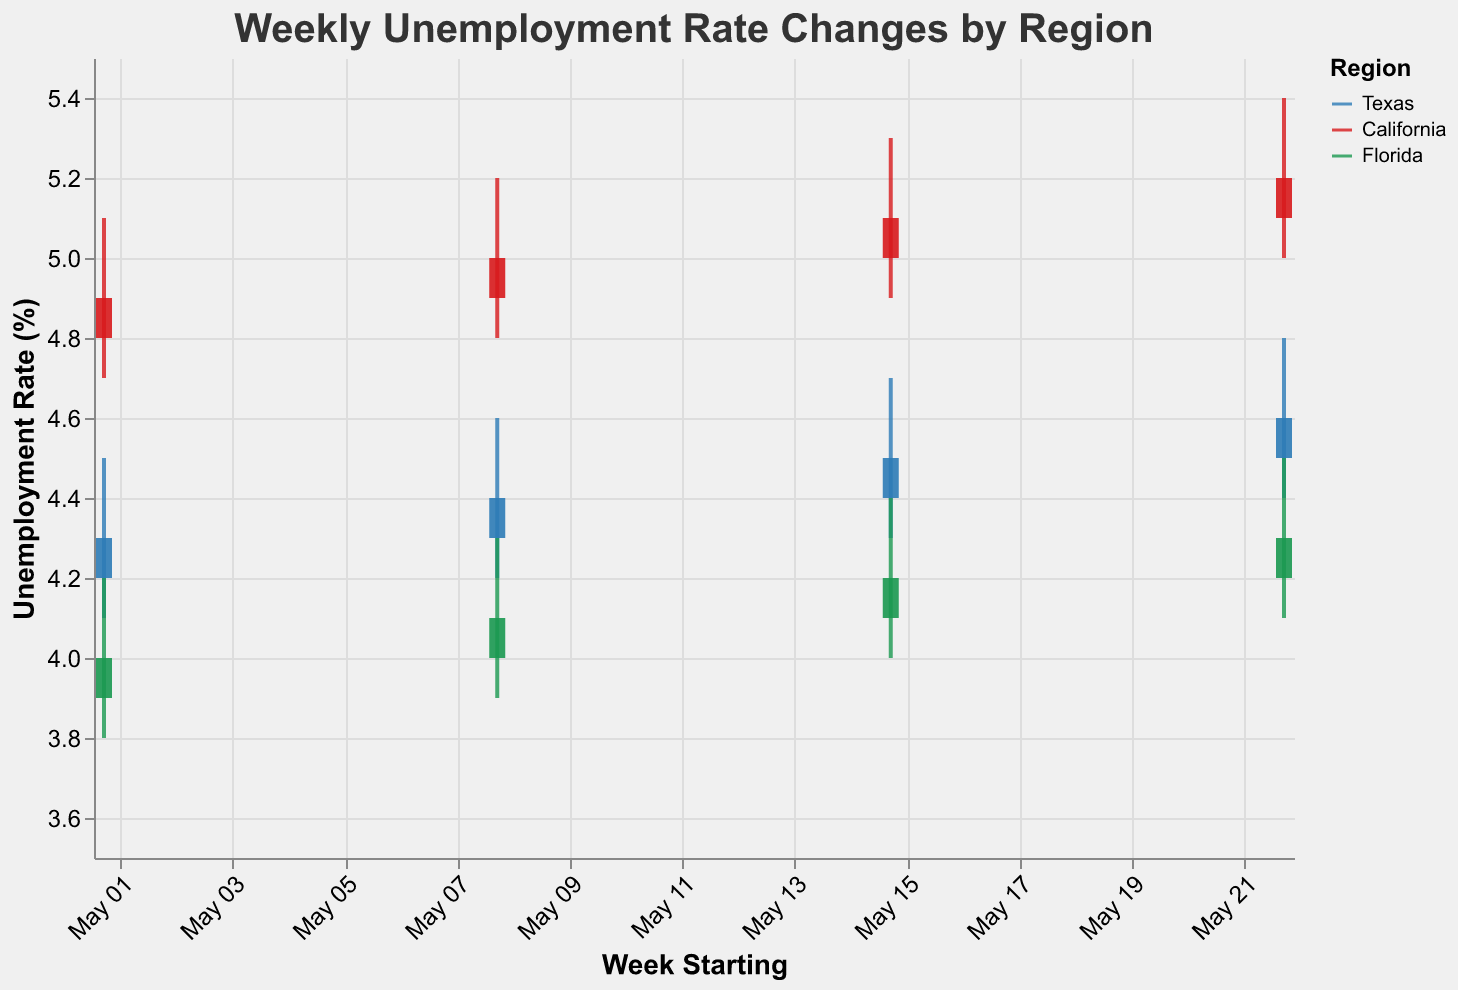How does the unemployment rate in Texas change over the four weeks in May 2023? In the chart, observe the Close values for Texas from May 1 to May 22. The values are 4.3%, 4.4%, 4.5%, and 4.6%, respectively.
Answer: It increases from 4.3% to 4.6% Which region had the highest starting unemployment rate in the first week of May 2023? Check the Open values for all regions for the date of May 1, 2023. California has the highest starting unemployment rate at 4.8%.
Answer: California What is the average unemployment rate in Florida over the four weeks of May 2023? Sum the Close values for Florida over the four weeks (4.0 + 4.1 + 4.2 + 4.3 = 16.6), then divide by the number of weeks (16.6 / 4 = 4.15).
Answer: 4.15% Which region shows the most significant increase in the unemployment rate from the start to the end of May 2023? Compare the difference between the first and last Close values for each region: Texas (4.6 - 4.3 = 0.3), California (5.2 - 4.9 = 0.3), Florida (4.3 - 4.0 = 0.3). All regions have an equal increase of 0.3%.
Answer: All regions have equal increases How does the range of unemployment rates in Texas compare with California in the third week of May 2023? For the week starting on May 15, compare the High and Low values for Texas (4.7 - 4.3 = 0.4) and California (5.3 - 4.9 = 0.4). The range is the same for both regions, 0.4%.
Answer: The range is the same, 0.4% Which region had the lowest unemployment rate at the end of the third week of May 2023? Look at the Close values for all regions for the date of May 15, 2023. Florida's is the lowest at 4.2%.
Answer: Florida On which date was the unemployment rate variability the highest in California? Find the date with the highest difference between High and Low for California. The maximum difference is 5.4 - 5.0 = 0.4 on May 22.
Answer: May 22 Compare the unemployment rate variability between Texas and Florida in the second week of May 2023. Check the High and Low values for Texas (4.6 - 4.2 = 0.4) and Florida (4.3 - 3.9 = 0.4) for the week starting on May 8. The variability is the same, 0.4%.
Answer: The variability is the same, 0.4% Between Texas and California, which region had a consistently higher unemployment rate throughout May 2023? Compare the Close values for Texas and California over the four weeks. California's values (4.9, 5.0, 5.1, 5.2) are higher than Texas' values (4.3, 4.4, 4.5, 4.6) for each week.
Answer: California What is the trend in unemployment rates in California from the beginning to the end of May 2023? Observe the Close values for California over the weeks (4.9, 5.0, 5.1, 5.2). The trend shows a gradual increase in unemployment rate.
Answer: Increasing trend 